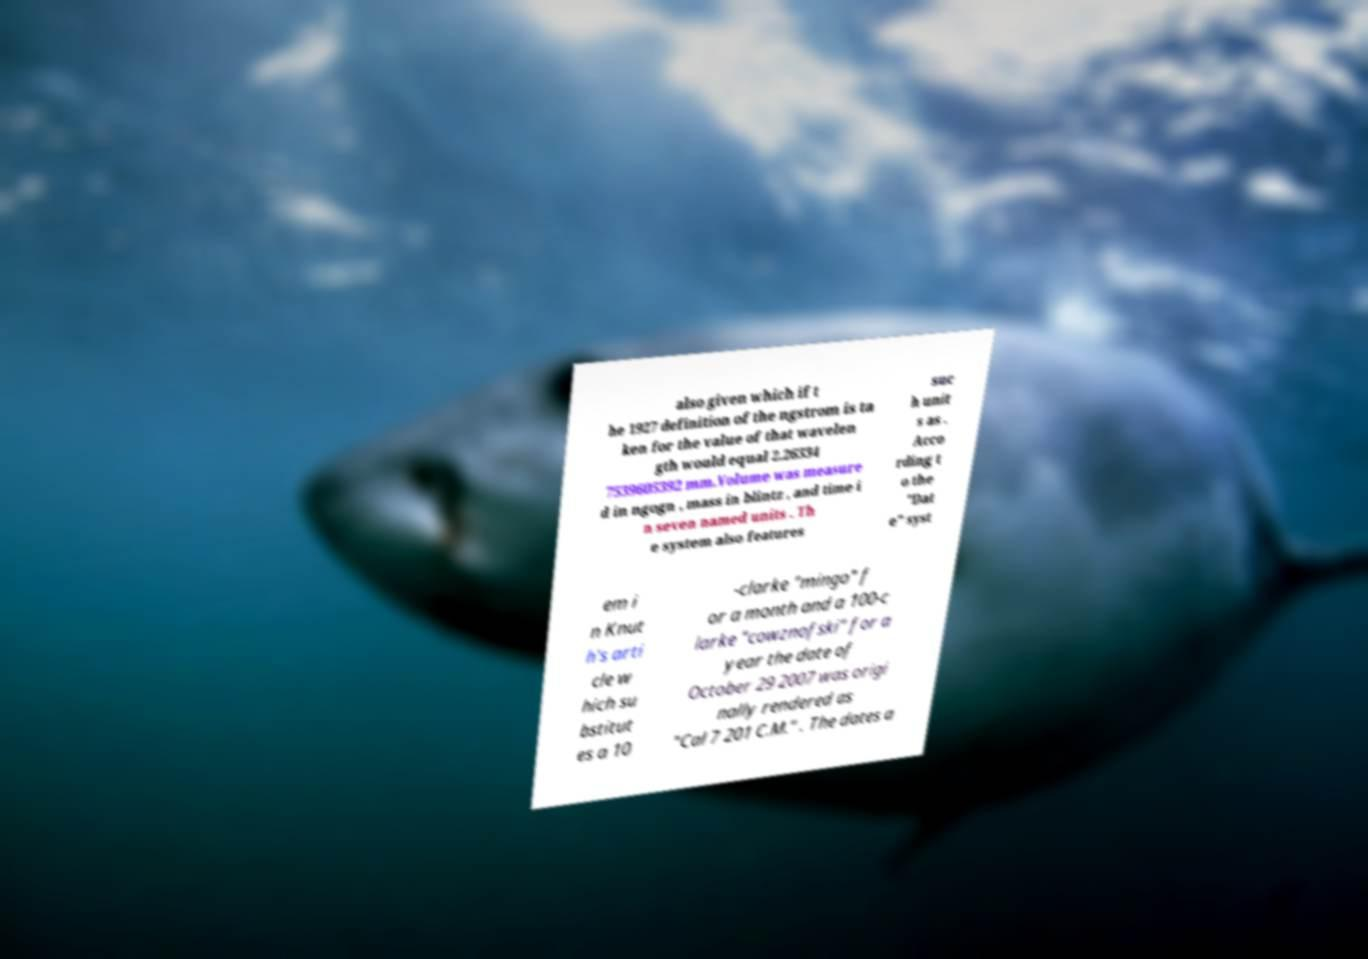What messages or text are displayed in this image? I need them in a readable, typed format. also given which if t he 1927 definition of the ngstrom is ta ken for the value of that wavelen gth would equal 2.26334 7539605392 mm.Volume was measure d in ngogn , mass in blintz , and time i n seven named units . Th e system also features suc h unit s as . Acco rding t o the "Dat e" syst em i n Knut h's arti cle w hich su bstitut es a 10 -clarke "mingo" f or a month and a 100-c larke "cowznofski" for a year the date of October 29 2007 was origi nally rendered as "Cal 7 201 C.M." . The dates a 